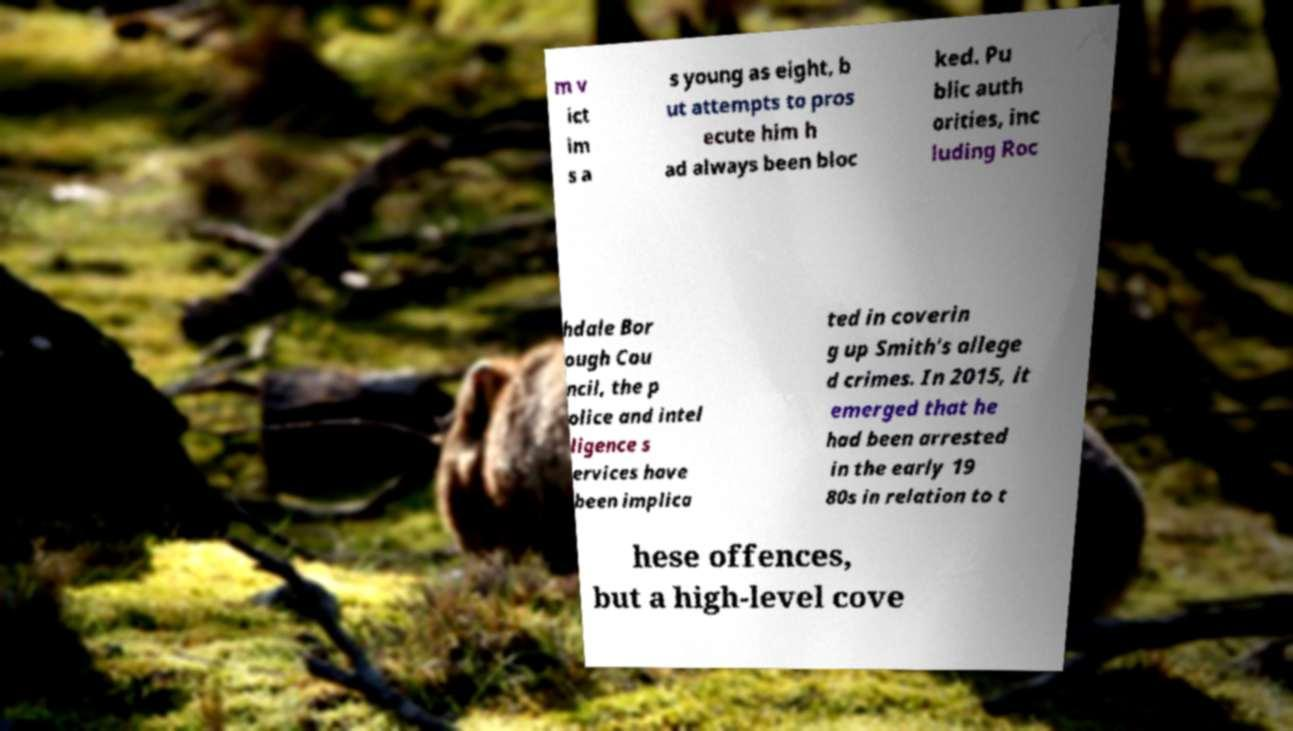Can you read and provide the text displayed in the image?This photo seems to have some interesting text. Can you extract and type it out for me? m v ict im s a s young as eight, b ut attempts to pros ecute him h ad always been bloc ked. Pu blic auth orities, inc luding Roc hdale Bor ough Cou ncil, the p olice and intel ligence s ervices have been implica ted in coverin g up Smith's allege d crimes. In 2015, it emerged that he had been arrested in the early 19 80s in relation to t hese offences, but a high-level cove 